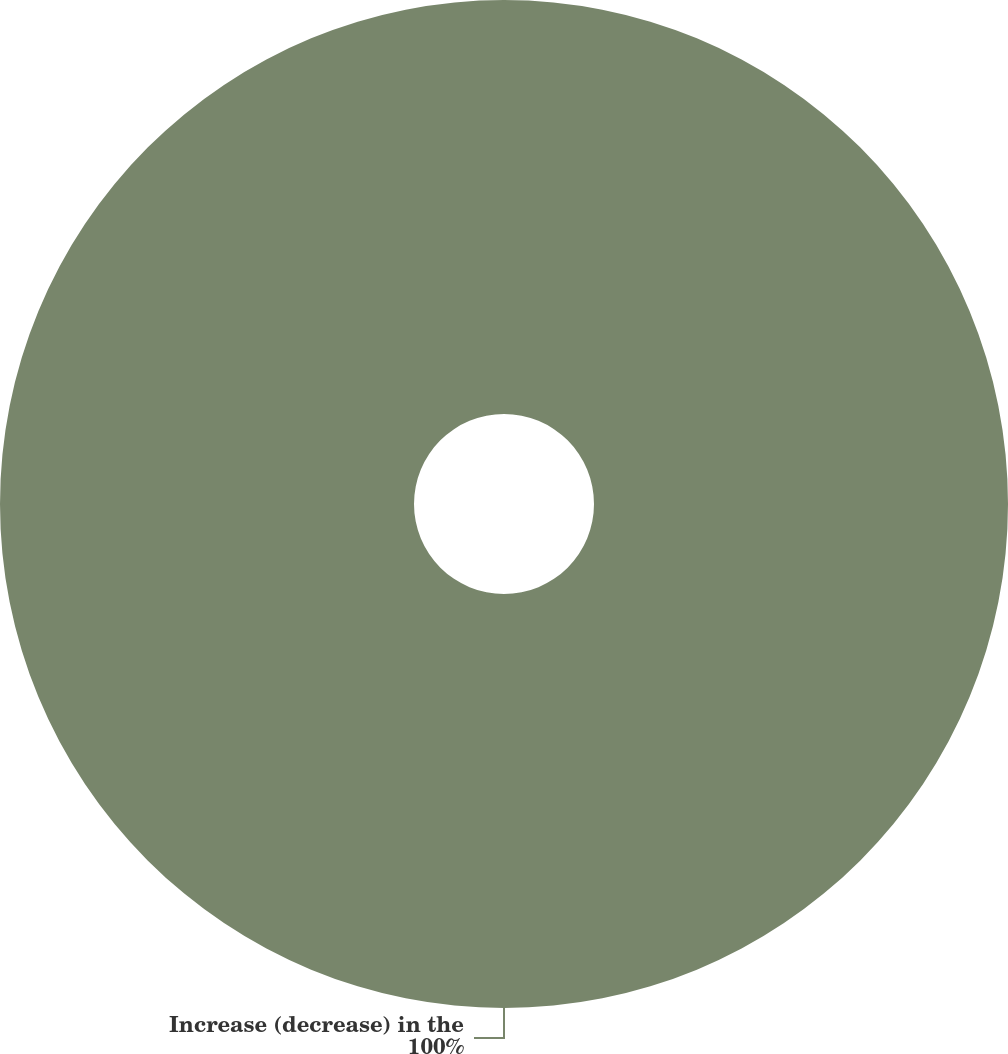Convert chart to OTSL. <chart><loc_0><loc_0><loc_500><loc_500><pie_chart><fcel>Increase (decrease) in the<nl><fcel>100.0%<nl></chart> 